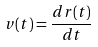<formula> <loc_0><loc_0><loc_500><loc_500>v ( t ) = \frac { d r ( t ) } { d t }</formula> 